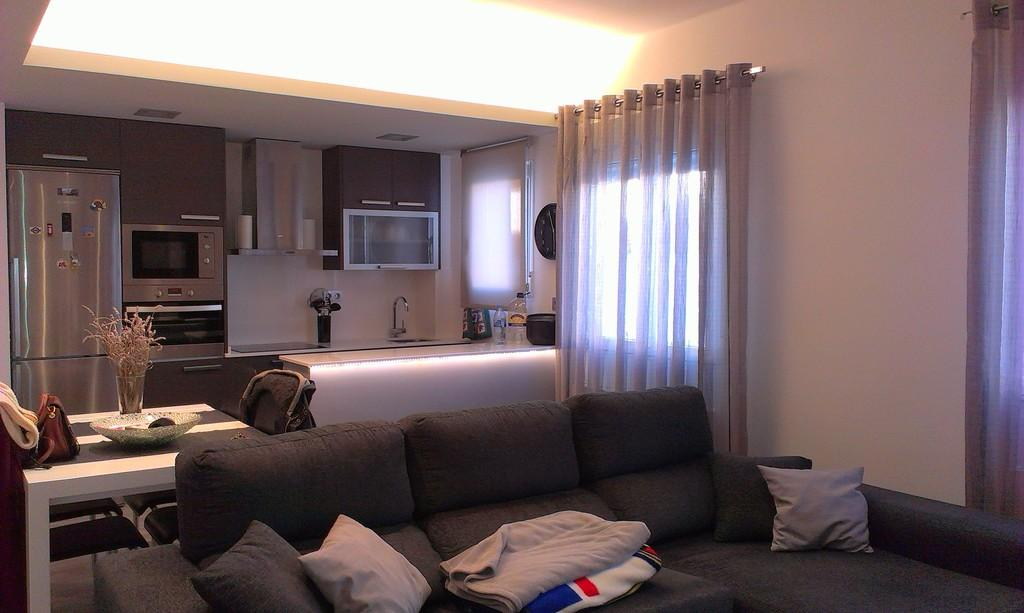What type of furniture is in the image? There is a sofa in the image. What is on the sofa? There are cushions on the sofa. What appliances can be seen in the background of the image? There is a refrigerator, a microwave, and a sink in the background of the image. What type of fiction is the parent reading to the child in the image? There is no parent or child present in the image, and no fiction is being read. 